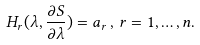<formula> <loc_0><loc_0><loc_500><loc_500>H _ { r } ( \lambda , \frac { \partial S } { \partial \lambda } ) = a _ { r } \, , \, r = 1 , \dots , n .</formula> 